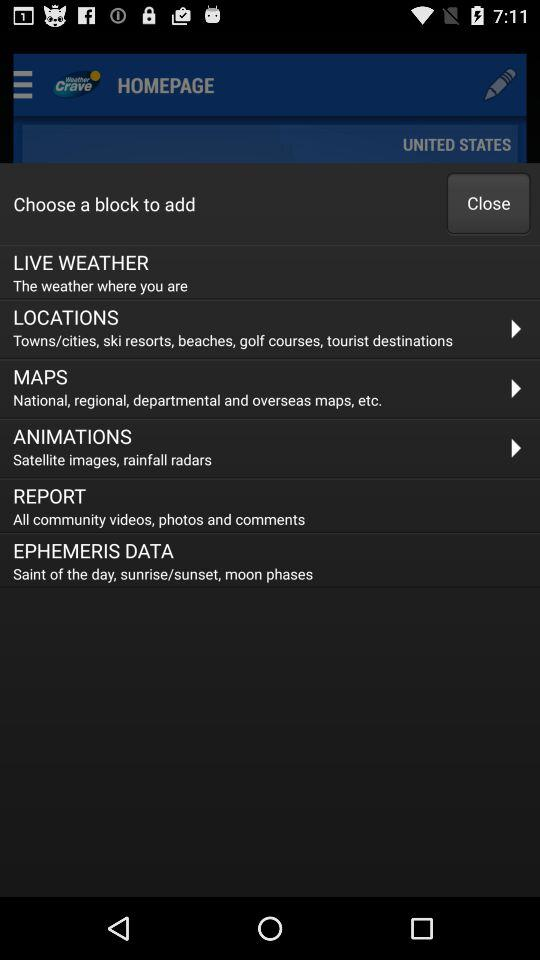What is the application name? The application name is "Weather Crave". 